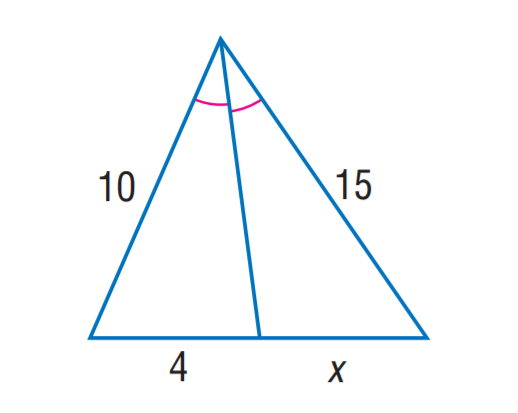Question: Find x.
Choices:
A. 4
B. 6
C. 8
D. 12
Answer with the letter. Answer: B 